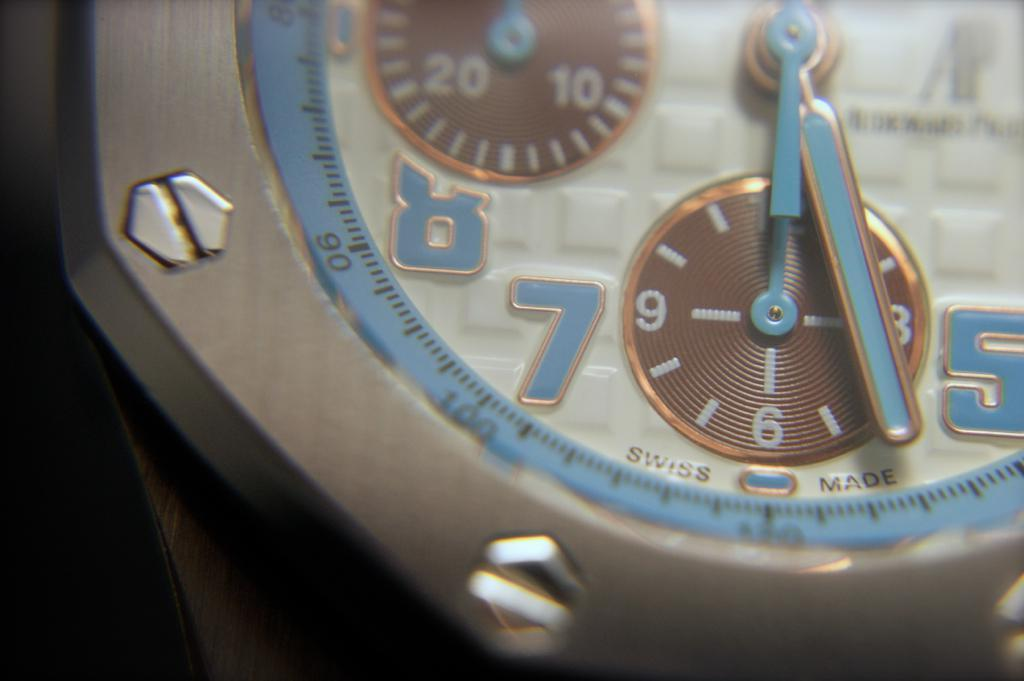<image>
Relay a brief, clear account of the picture shown. Swiss metallic watch with uncovered hexagonal screwheads on outer frame, retro chunky numbers on face. 